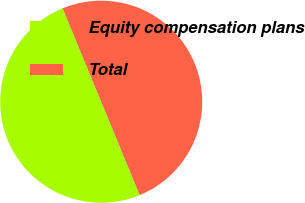Convert chart to OTSL. <chart><loc_0><loc_0><loc_500><loc_500><pie_chart><fcel>Equity compensation plans<fcel>Total<nl><fcel>50.0%<fcel>50.0%<nl></chart> 